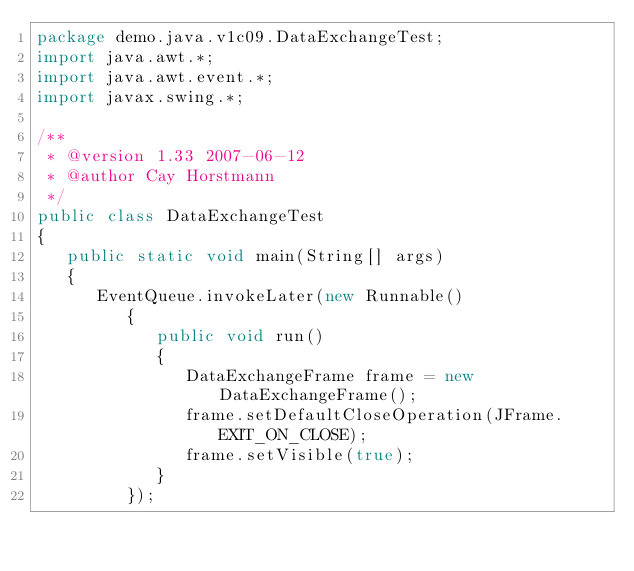<code> <loc_0><loc_0><loc_500><loc_500><_Java_>package demo.java.v1c09.DataExchangeTest;
import java.awt.*;
import java.awt.event.*;
import javax.swing.*;

/**
 * @version 1.33 2007-06-12
 * @author Cay Horstmann
 */
public class DataExchangeTest
{
   public static void main(String[] args)
   {
      EventQueue.invokeLater(new Runnable()
         {
            public void run()
            {
               DataExchangeFrame frame = new DataExchangeFrame();
               frame.setDefaultCloseOperation(JFrame.EXIT_ON_CLOSE);
               frame.setVisible(true);
            }
         });</code> 